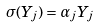<formula> <loc_0><loc_0><loc_500><loc_500>\sigma ( Y _ { j } ) = \alpha _ { j } Y _ { j }</formula> 